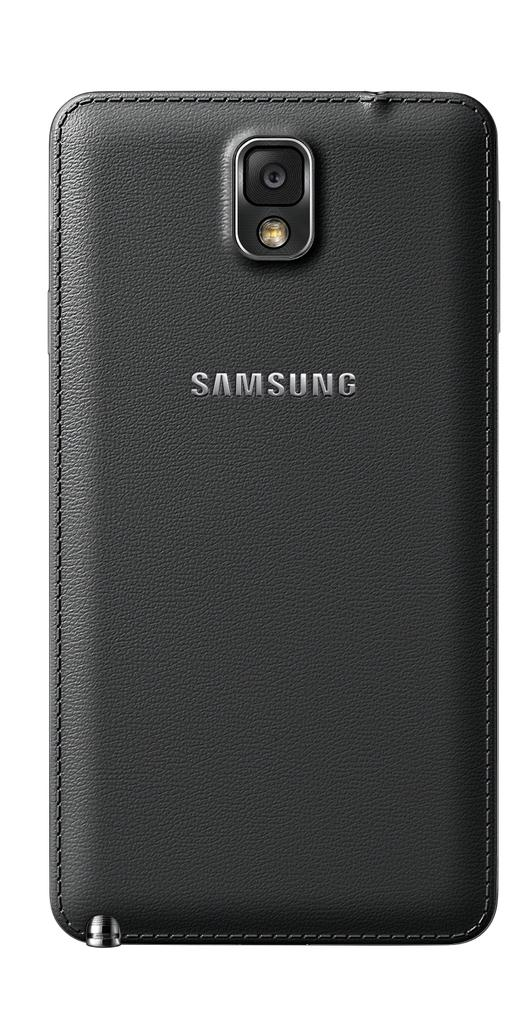Provide a one-sentence caption for the provided image. The black leather cell phone case is made for Samsung phones. 